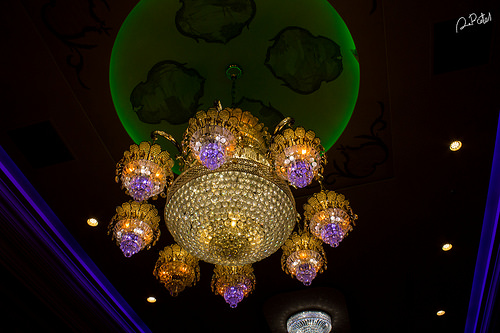<image>
Can you confirm if the light is to the left of the ceiling? No. The light is not to the left of the ceiling. From this viewpoint, they have a different horizontal relationship. 